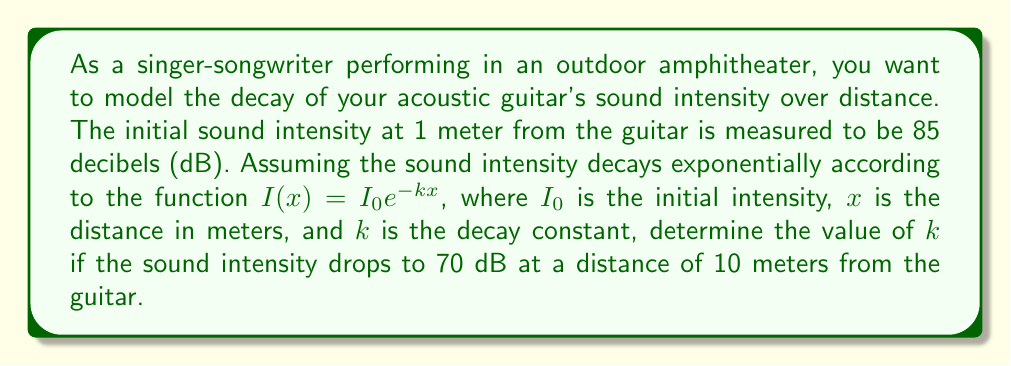What is the answer to this math problem? To solve this problem, we'll follow these steps:

1) First, recall that the decibel scale is logarithmic. The relationship between intensity $I$ and decibels $dB$ is given by:

   $dB = 10 \log_{10}(\frac{I}{I_{ref}})$

   where $I_{ref}$ is a reference intensity.

2) We're given that the intensity decays according to $I(x) = I_0 e^{-kx}$. We need to find $k$.

3) We have two points:
   At $x = 1$ m, $dB = 85$
   At $x = 10$ m, $dB = 70$

4) Let's call the intensity at 1 m $I_1$ and at 10 m $I_{10}$. We can write:

   $85 = 10 \log_{10}(\frac{I_1}{I_{ref}})$
   $70 = 10 \log_{10}(\frac{I_{10}}{I_{ref}})$

5) Subtracting these equations:

   $85 - 70 = 10 \log_{10}(\frac{I_1}{I_{ref}}) - 10 \log_{10}(\frac{I_{10}}{I_{ref}})$
   $15 = 10 \log_{10}(\frac{I_1}{I_{10}})$

6) Simplify:

   $1.5 = \log_{10}(\frac{I_1}{I_{10}})$

7) Take $10$ to the power of both sides:

   $10^{1.5} = \frac{I_1}{I_{10}} \approx 31.62$

8) Now, using our exponential decay function:

   $\frac{I_1}{I_{10}} = \frac{I_0 e^{-k(1)}}{I_0 e^{-k(10)}} = \frac{e^{-k}}{e^{-10k}} = e^{9k} \approx 31.62$

9) Take the natural log of both sides:

   $9k = \ln(31.62)$

10) Solve for $k$:

    $k = \frac{\ln(31.62)}{9} \approx 0.3811$

Therefore, the decay constant $k$ is approximately 0.3811.
Answer: $k \approx 0.3811$ 